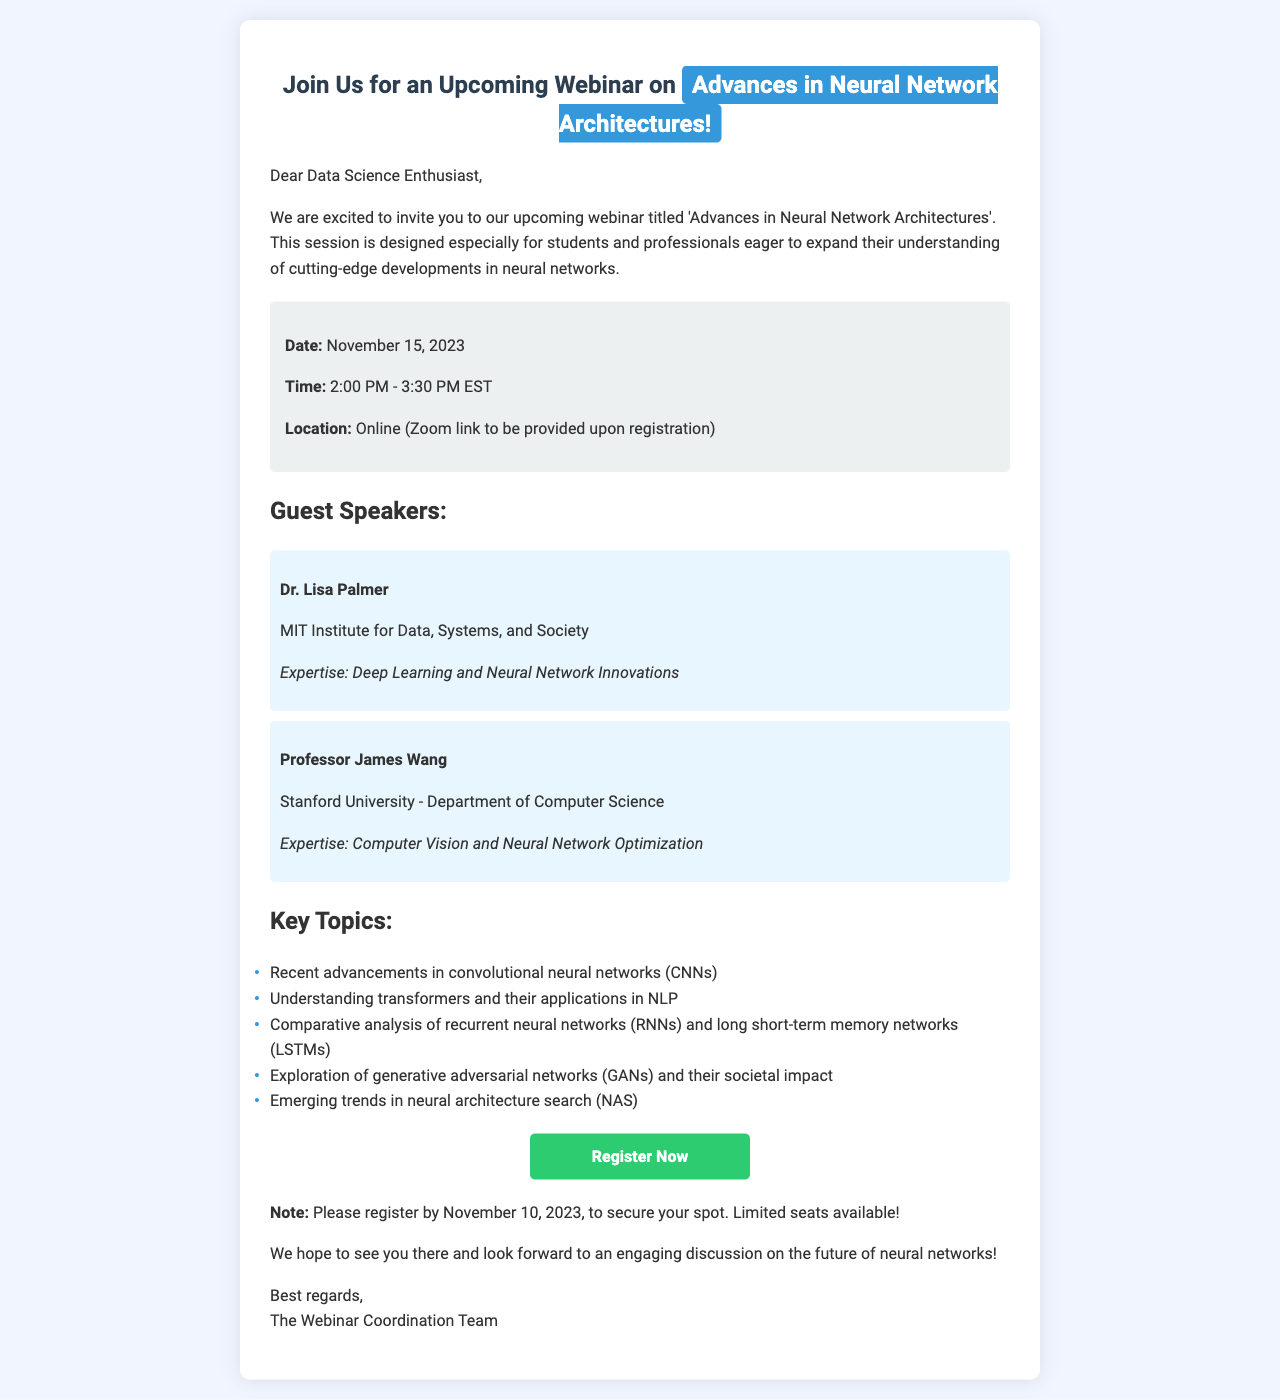What is the title of the webinar? The title of the webinar is mentioned in the opening paragraph of the document.
Answer: Advances in Neural Network Architectures Who are the guest speakers? The guest speakers are listed under the section titled "Guest Speakers."
Answer: Dr. Lisa Palmer and Professor James Wang What date is the webinar scheduled for? The webinar date is specified in the details section of the document.
Answer: November 15, 2023 What topics will be covered in the webinar? The key topics to be covered are listed in the section titled "Key Topics."
Answer: Recent advancements in convolutional neural networks (CNNs) and others What time does the webinar begin? The starting time of the webinar is given in the details section.
Answer: 2:00 PM When is the registration deadline? The registration deadline is noted in the last paragraph of the document.
Answer: November 10, 2023 Where will the webinar take place? The location for the event is mentioned in the details section.
Answer: Online (Zoom link to be provided upon registration) What is the format for registering for the webinar? The registration format is indicated by the presence of a link in the document.
Answer: Link to register What is the host organization of the webinar? The host organization is typically mentioned in the sign-off of the email.
Answer: The Webinar Coordination Team 